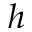<formula> <loc_0><loc_0><loc_500><loc_500>h</formula> 